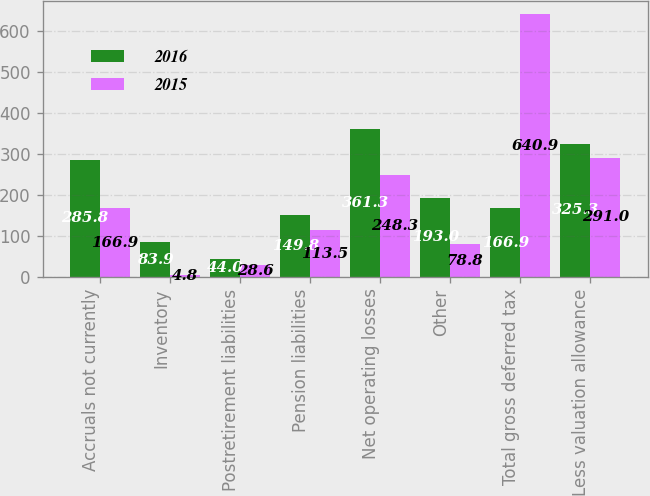<chart> <loc_0><loc_0><loc_500><loc_500><stacked_bar_chart><ecel><fcel>Accruals not currently<fcel>Inventory<fcel>Postretirement liabilities<fcel>Pension liabilities<fcel>Net operating losses<fcel>Other<fcel>Total gross deferred tax<fcel>Less valuation allowance<nl><fcel>2016<fcel>285.8<fcel>83.9<fcel>44<fcel>149.8<fcel>361.3<fcel>193<fcel>166.9<fcel>325.3<nl><fcel>2015<fcel>166.9<fcel>4.8<fcel>28.6<fcel>113.5<fcel>248.3<fcel>78.8<fcel>640.9<fcel>291<nl></chart> 